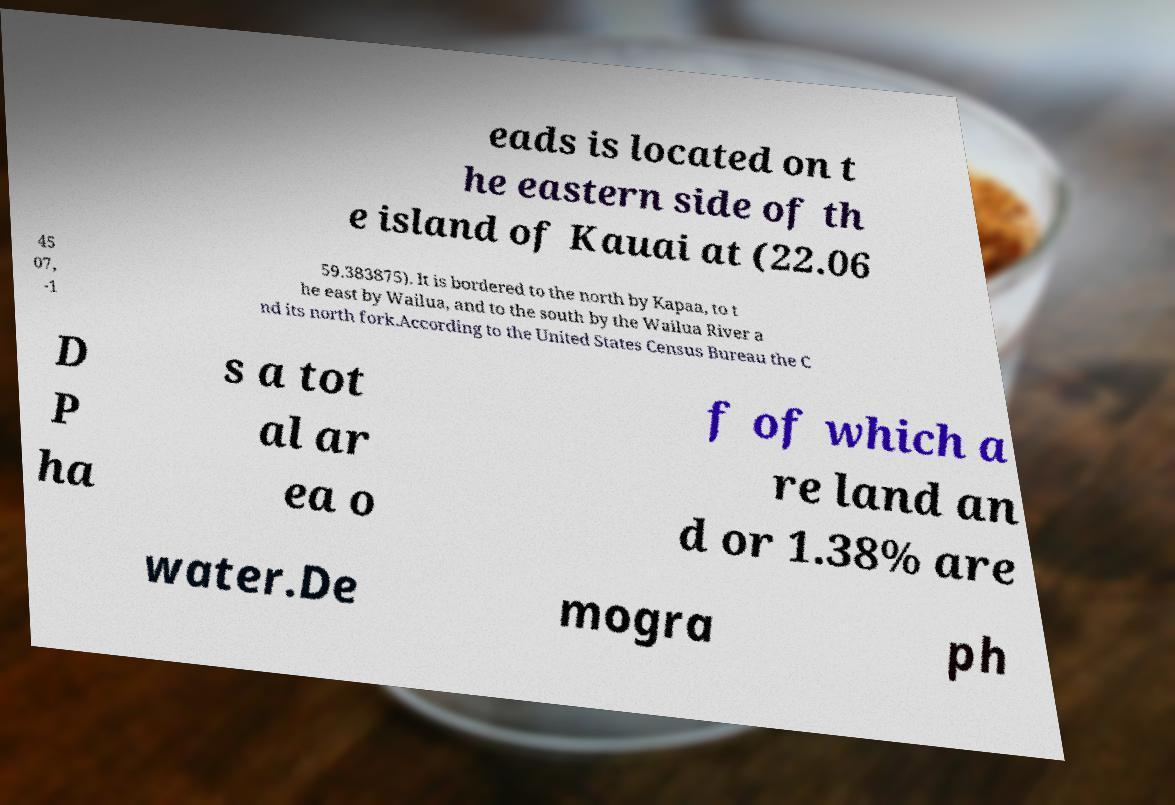I need the written content from this picture converted into text. Can you do that? eads is located on t he eastern side of th e island of Kauai at (22.06 45 07, -1 59.383875). It is bordered to the north by Kapaa, to t he east by Wailua, and to the south by the Wailua River a nd its north fork.According to the United States Census Bureau the C D P ha s a tot al ar ea o f of which a re land an d or 1.38% are water.De mogra ph 